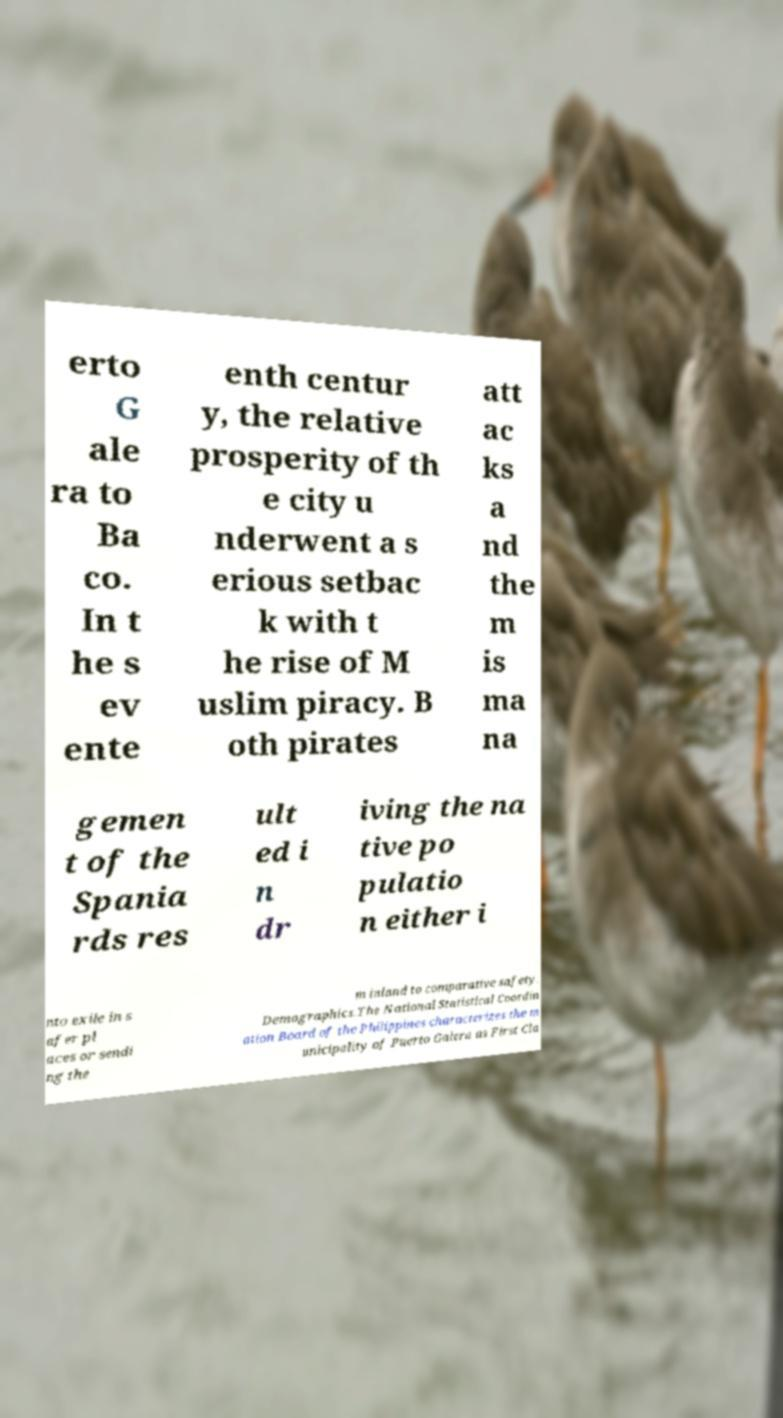Please identify and transcribe the text found in this image. erto G ale ra to Ba co. In t he s ev ente enth centur y, the relative prosperity of th e city u nderwent a s erious setbac k with t he rise of M uslim piracy. B oth pirates att ac ks a nd the m is ma na gemen t of the Spania rds res ult ed i n dr iving the na tive po pulatio n either i nto exile in s afer pl aces or sendi ng the m inland to comparative safety. Demographics.The National Statistical Coordin ation Board of the Philippines characterizes the m unicipality of Puerto Galera as First Cla 